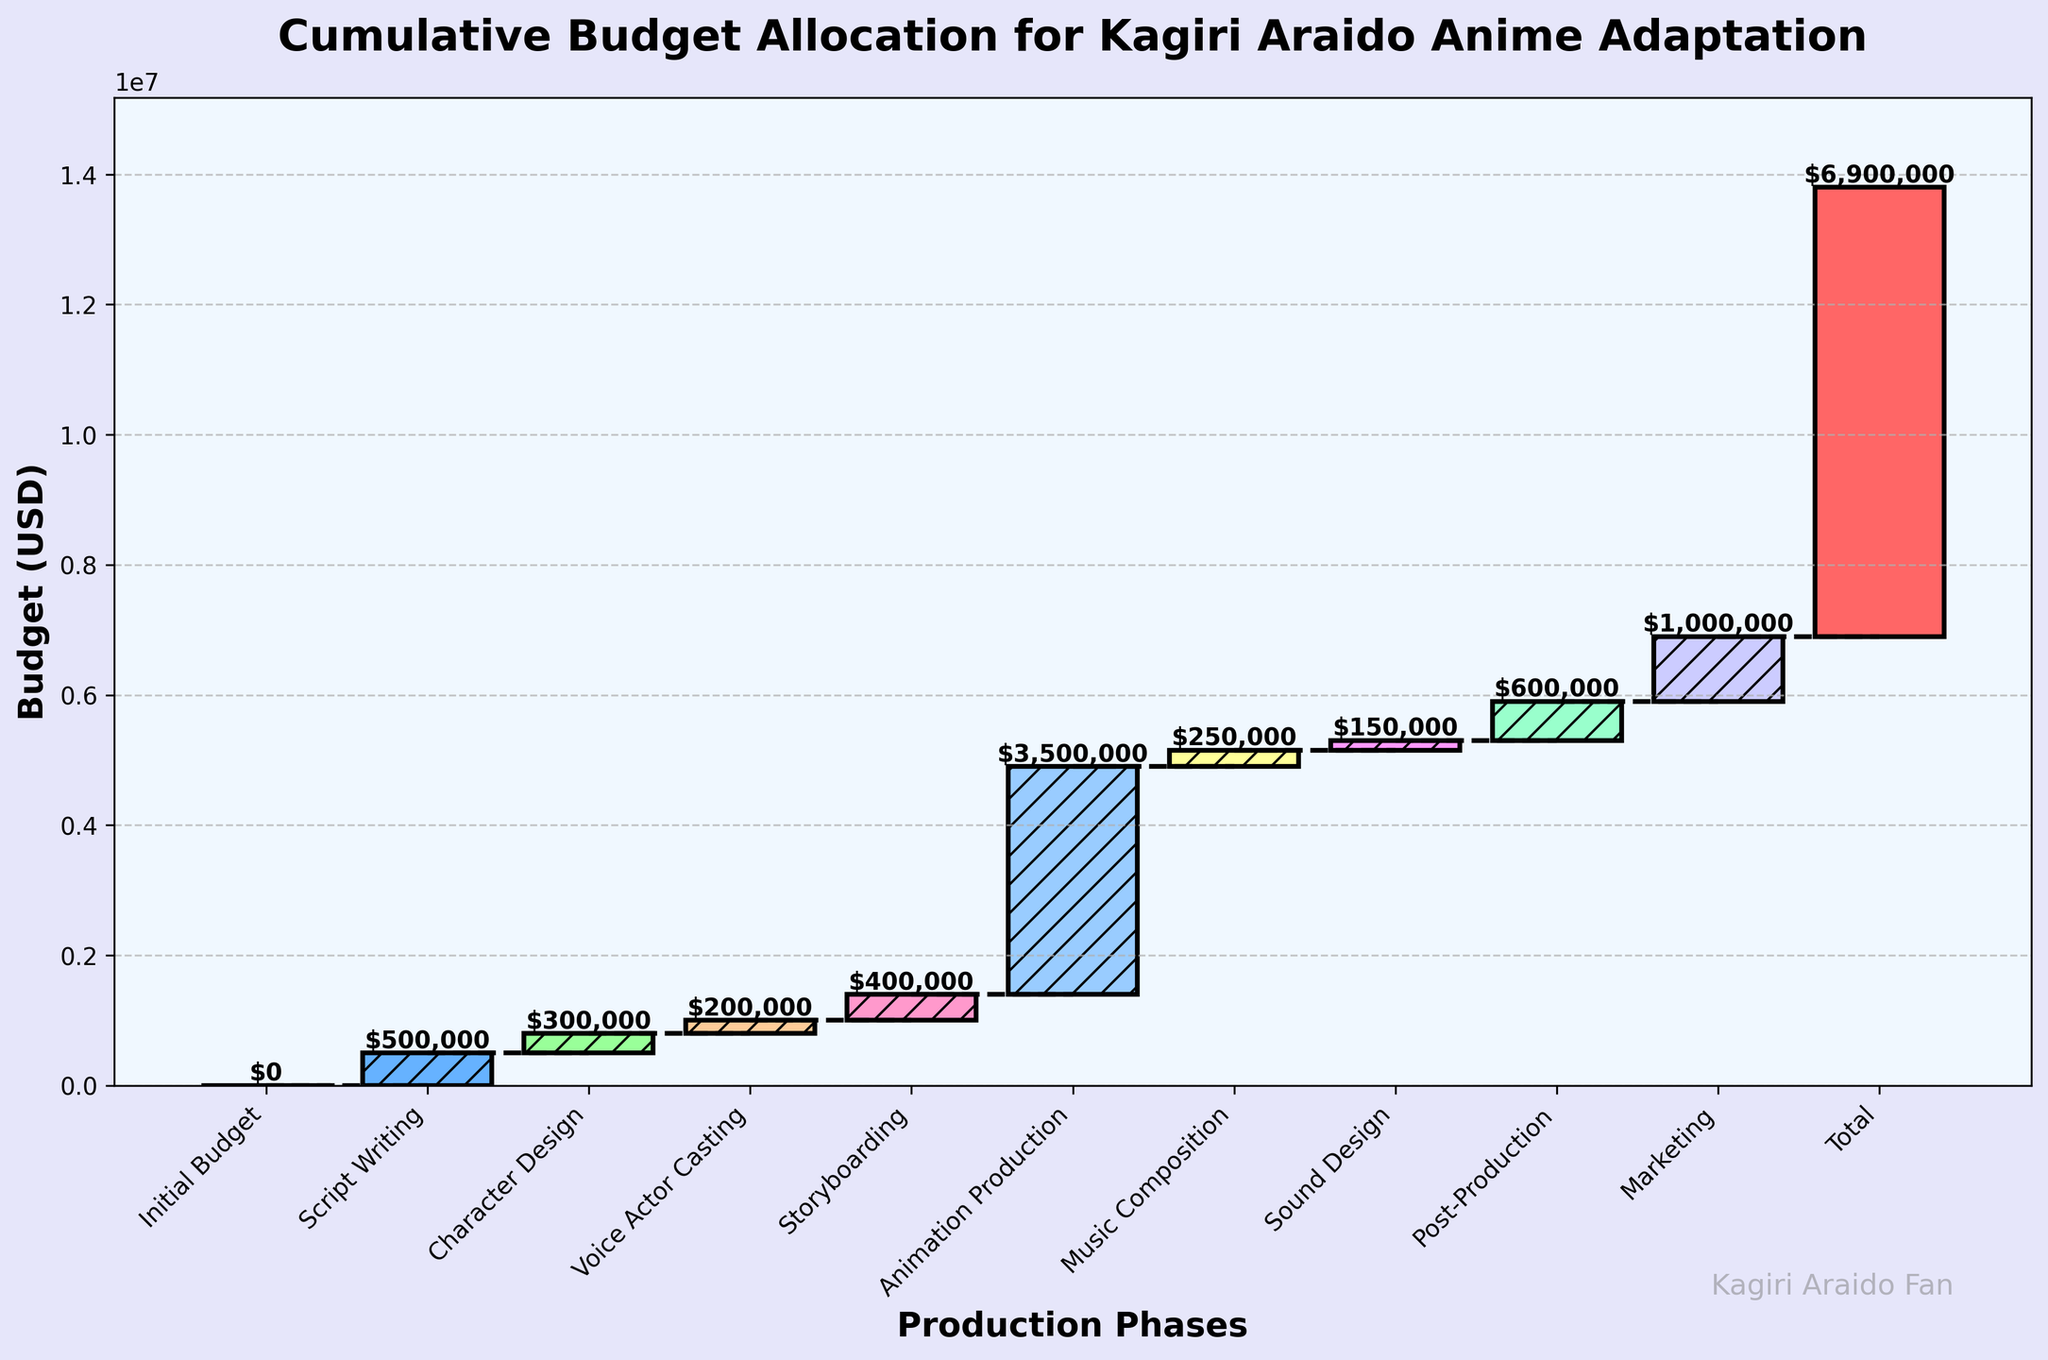How many production phases are there including the initial budget and total? The X-axis ticks in the plot display the production phases. Counting each label from left to right, including "Initial Budget" and "Total", gives the total number of phases.
Answer: 11 What is the total budget allocated for the new Kagiri Araido anime adaptation? The final label on the X-axis, "Total", and the corresponding value label "$6,900,000" at the top of the last bar indicate the total budget.
Answer: $6,900,000 Which production phase received the highest budget allocation? By examining the heights of each bar in the waterfall chart, the "Animation Production" phase stands out as the tallest with a value of $3,500,000.
Answer: Animation Production What is the combined budget for Voice Actor Casting and Music Composition? The value for Voice Actor Casting is $200,000, and for Music Composition, it's $250,000. Summing these values gives $200,000 + $250,000.
Answer: $450,000 How much more budget was allocated to Character Design compared to Sound Design? The value for Character Design is $300,000 and for Sound Design is $150,000. Subtracting these values gives $300,000 - $150,000.
Answer: $150,000 What is the difference between the budgets for Post-Production and Script Writing? The value for Post-Production is $600,000, and for Script Writing, it's $500,000. Subtracting these values gives $600,000 - $500,000.
Answer: $100,000 What proportion of the total budget was spent on Marketing? The total budget is $6,900,000 and the marketing budget is $1,000,000. Dividing the marketing budget by the total and converting to a percentage gives ($1,000,000 / $6,900,000) * 100%.
Answer: ≈14.49% What is the cumulative budget after the Animation Production phase? The cumulative budget at each phase is represented by the top of each bar. The top of the Animation Production bar, referring to the value at that cumulative point, is $4,900,000.
Answer: $4,900,000 